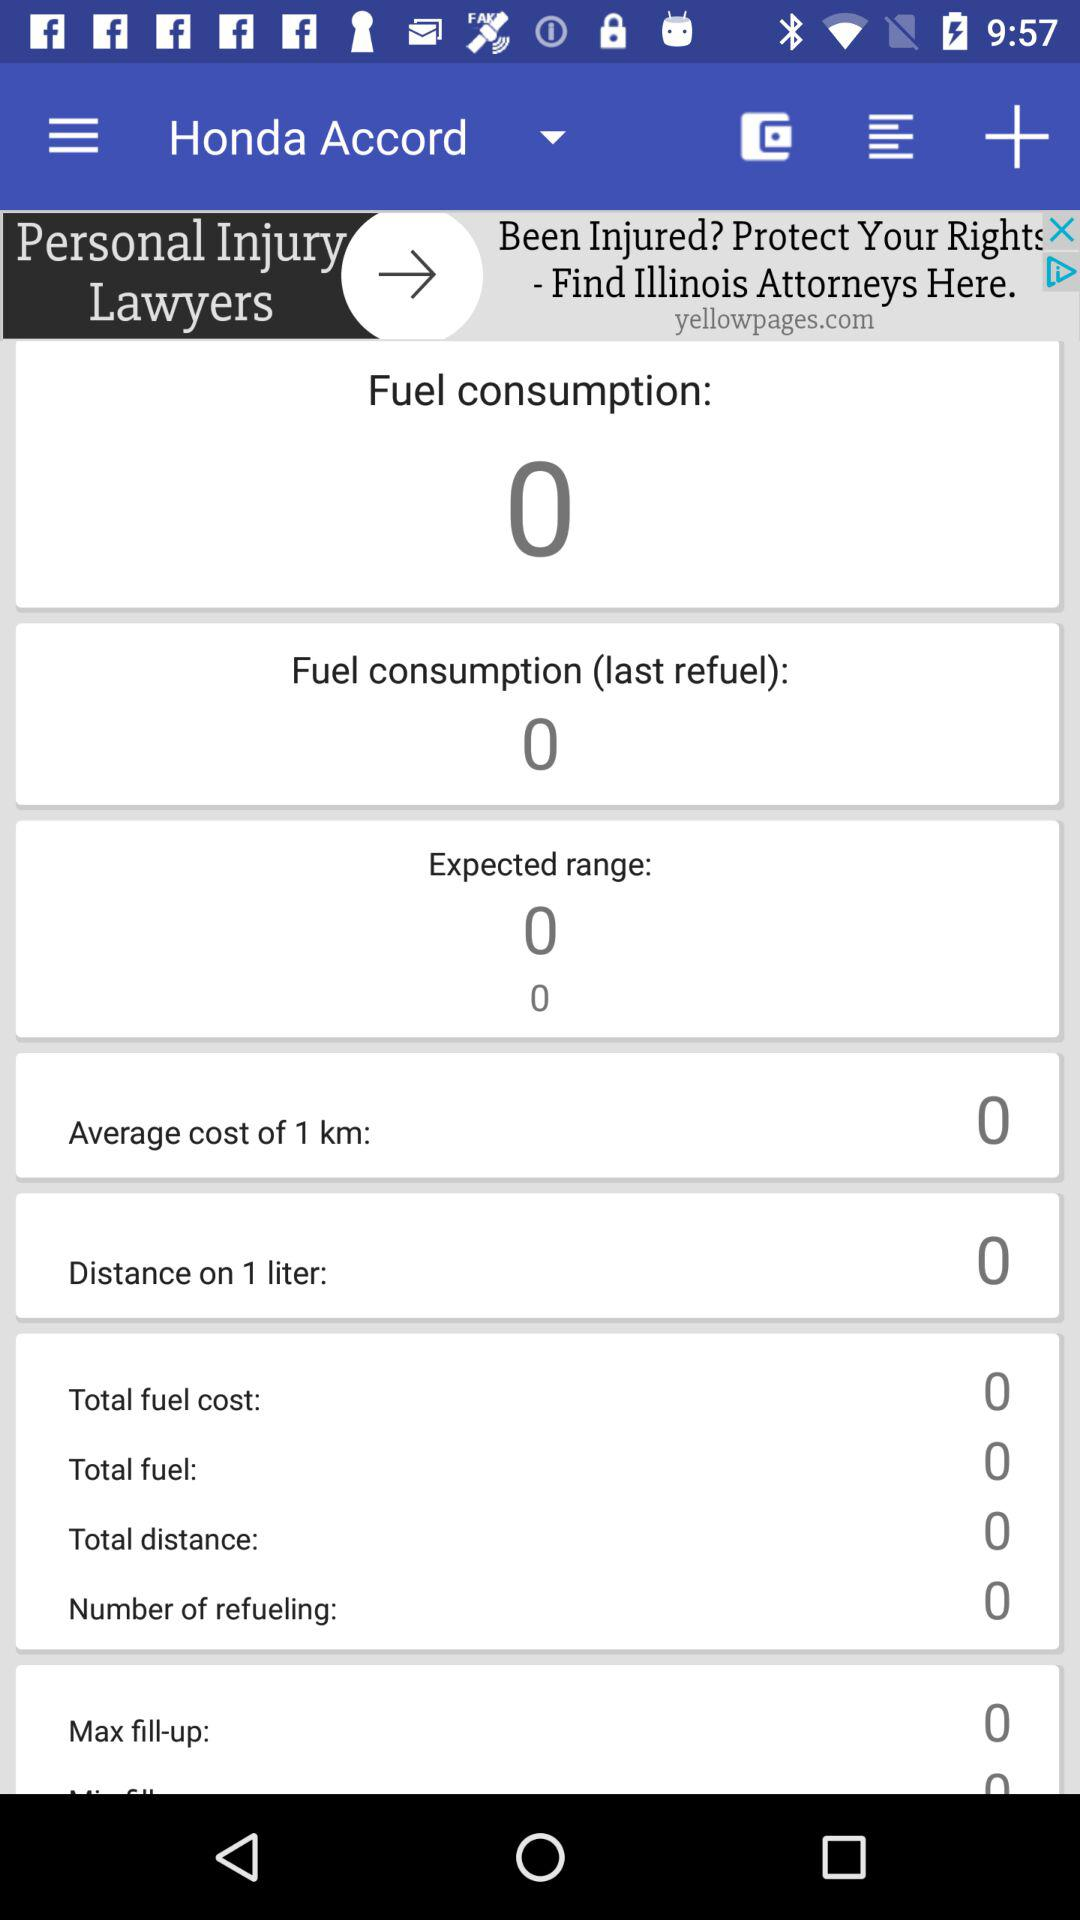What is the average cost of 1 km? The average cost of 1 km is 0. 